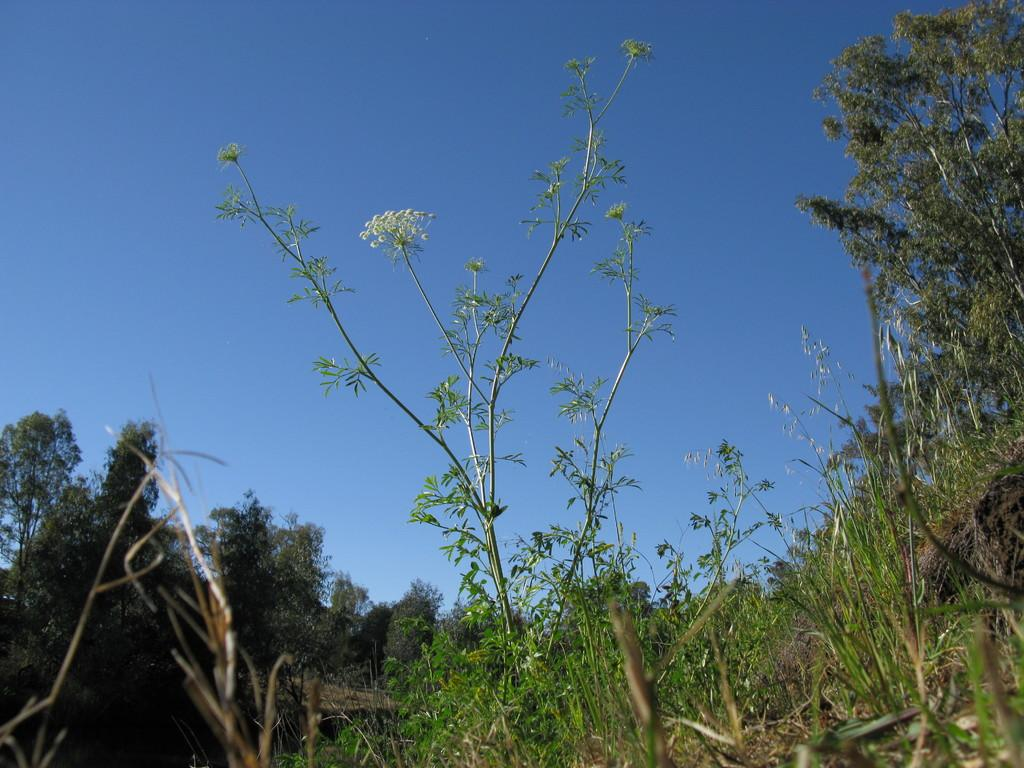What type of vegetation or plants can be seen in the image? There is greenery in the image, which suggests the presence of plants or vegetation. Can you see the sun in the image? The provided facts do not mention the presence of the sun in the image, so we cannot determine if it is visible or not. Are there any ducks in the image? The provided facts do not mention the presence of ducks in the image, so we cannot determine if they are present or not. 